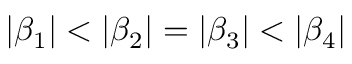<formula> <loc_0><loc_0><loc_500><loc_500>\left | \beta _ { 1 } \right | < \left | \beta _ { 2 } \right | = \left | \beta _ { 3 } \right | < \left | \beta _ { 4 } \right |</formula> 